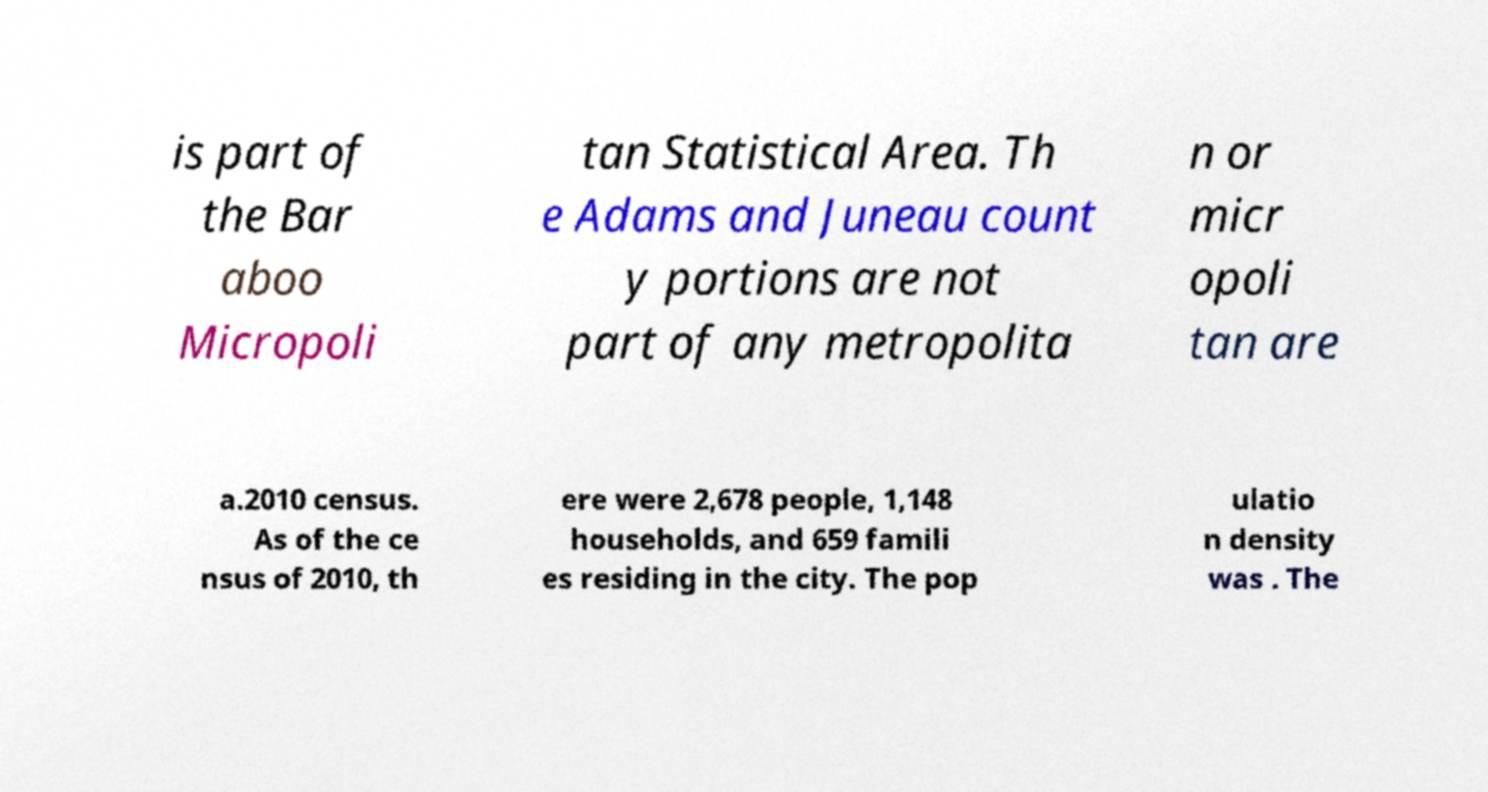Could you assist in decoding the text presented in this image and type it out clearly? is part of the Bar aboo Micropoli tan Statistical Area. Th e Adams and Juneau count y portions are not part of any metropolita n or micr opoli tan are a.2010 census. As of the ce nsus of 2010, th ere were 2,678 people, 1,148 households, and 659 famili es residing in the city. The pop ulatio n density was . The 